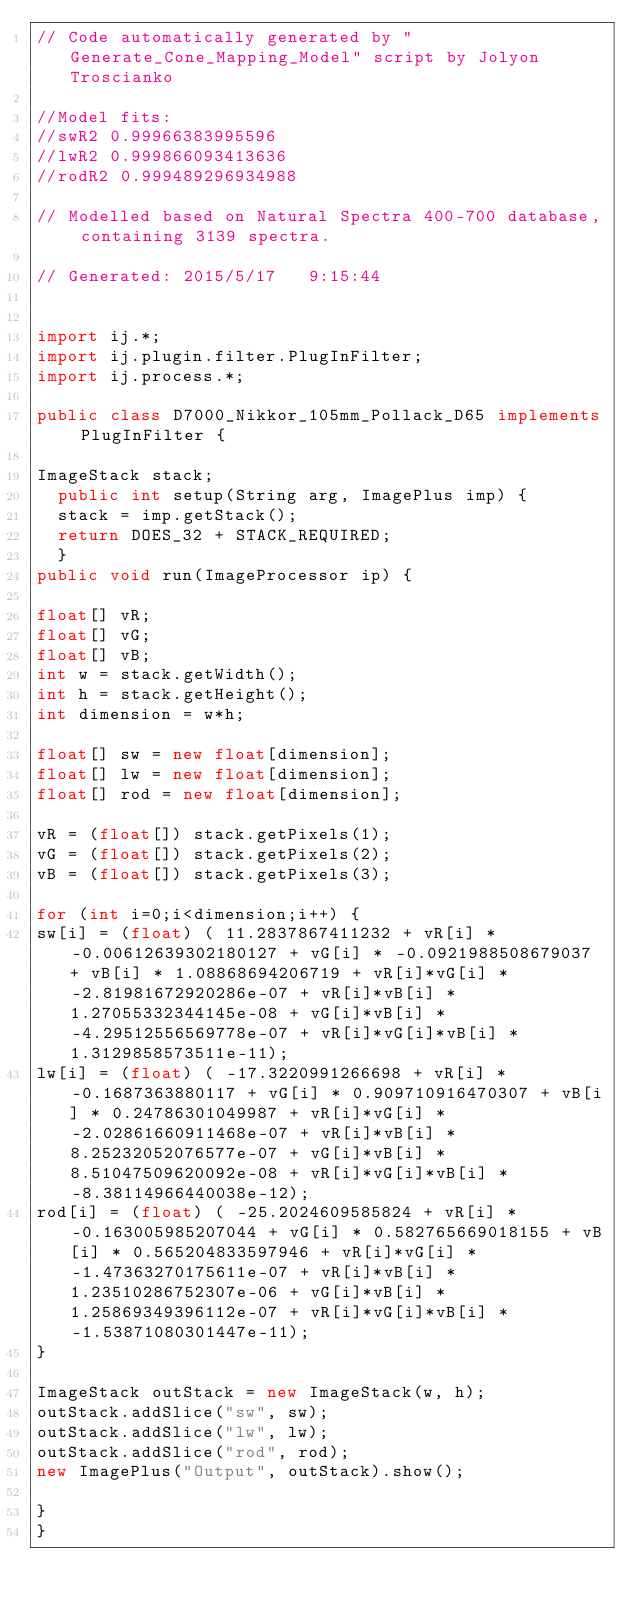<code> <loc_0><loc_0><loc_500><loc_500><_Java_>// Code automatically generated by "Generate_Cone_Mapping_Model" script by Jolyon Troscianko

//Model fits:
//swR2 0.99966383995596
//lwR2 0.999866093413636
//rodR2 0.999489296934988

// Modelled based on Natural Spectra 400-700 database, containing 3139 spectra.

// Generated: 2015/5/17   9:15:44


import ij.*;
import ij.plugin.filter.PlugInFilter;
import ij.process.*;

public class D7000_Nikkor_105mm_Pollack_D65 implements PlugInFilter {

ImageStack stack;
	public int setup(String arg, ImagePlus imp) { 
	stack = imp.getStack(); 
	return DOES_32 + STACK_REQUIRED; 
	}
public void run(ImageProcessor ip) {

float[] vR;
float[] vG;
float[] vB;
int w = stack.getWidth();
int h = stack.getHeight();
int dimension = w*h;

float[] sw = new float[dimension];
float[] lw = new float[dimension];
float[] rod = new float[dimension];

vR = (float[]) stack.getPixels(1);
vG = (float[]) stack.getPixels(2);
vB = (float[]) stack.getPixels(3);

for (int i=0;i<dimension;i++) {
sw[i] = (float) ( 11.2837867411232 + vR[i] * -0.00612639302180127 + vG[i] * -0.0921988508679037 + vB[i] * 1.08868694206719 + vR[i]*vG[i] * -2.81981672920286e-07 + vR[i]*vB[i] * 1.27055332344145e-08 + vG[i]*vB[i] * -4.29512556569778e-07 + vR[i]*vG[i]*vB[i] * 1.3129858573511e-11);
lw[i] = (float) ( -17.3220991266698 + vR[i] * -0.1687363880117 + vG[i] * 0.909710916470307 + vB[i] * 0.24786301049987 + vR[i]*vG[i] * -2.02861660911468e-07 + vR[i]*vB[i] * 8.25232052076577e-07 + vG[i]*vB[i] * 8.51047509620092e-08 + vR[i]*vG[i]*vB[i] * -8.38114966440038e-12);
rod[i] = (float) ( -25.2024609585824 + vR[i] * -0.163005985207044 + vG[i] * 0.582765669018155 + vB[i] * 0.565204833597946 + vR[i]*vG[i] * -1.47363270175611e-07 + vR[i]*vB[i] * 1.23510286752307e-06 + vG[i]*vB[i] * 1.25869349396112e-07 + vR[i]*vG[i]*vB[i] * -1.53871080301447e-11);
}

ImageStack outStack = new ImageStack(w, h);
outStack.addSlice("sw", sw);
outStack.addSlice("lw", lw);
outStack.addSlice("rod", rod);
new ImagePlus("Output", outStack).show();

}
}
</code> 